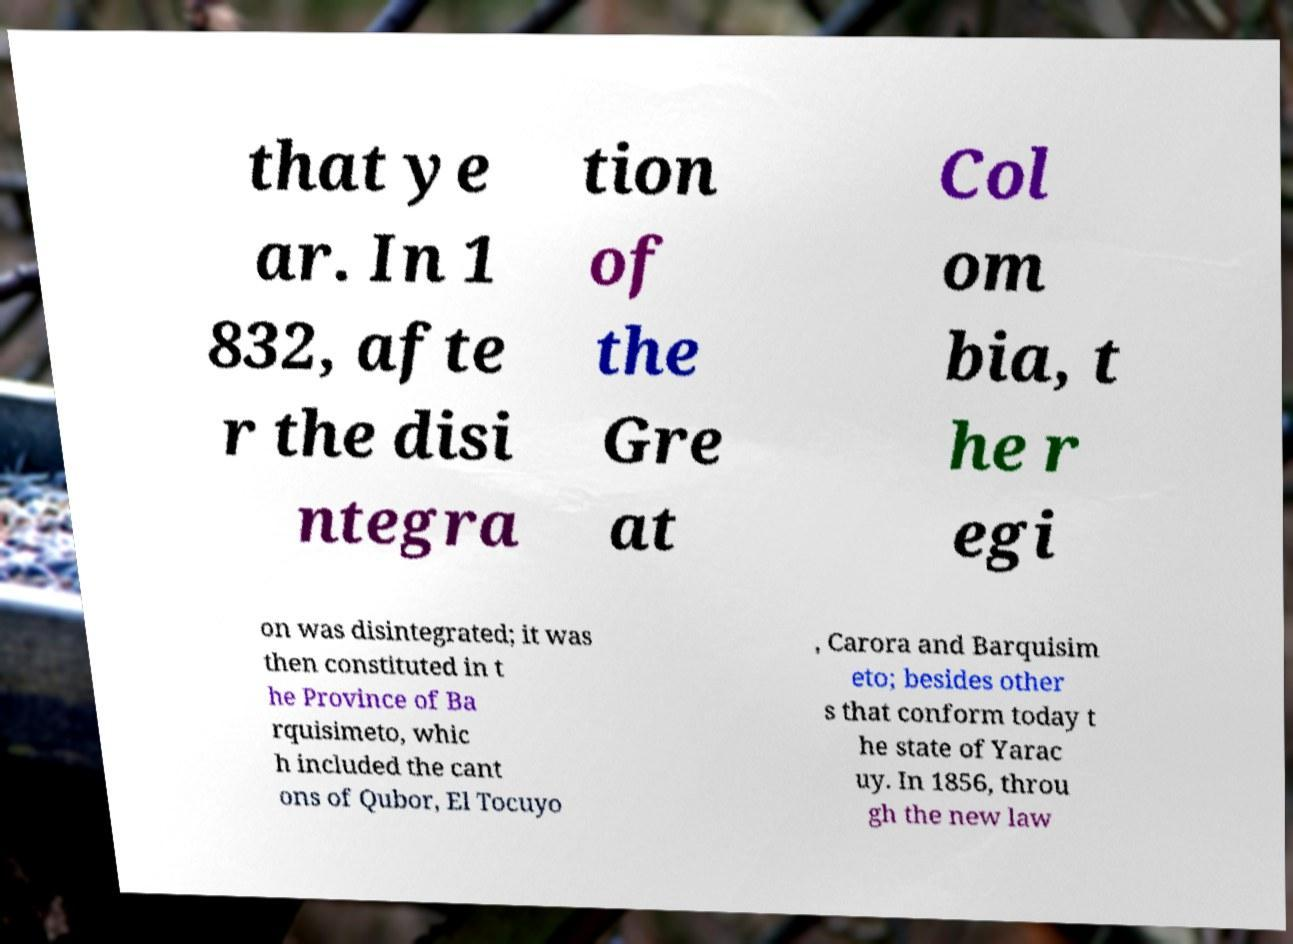Could you extract and type out the text from this image? that ye ar. In 1 832, afte r the disi ntegra tion of the Gre at Col om bia, t he r egi on was disintegrated; it was then constituted in t he Province of Ba rquisimeto, whic h included the cant ons of Qubor, El Tocuyo , Carora and Barquisim eto; besides other s that conform today t he state of Yarac uy. In 1856, throu gh the new law 